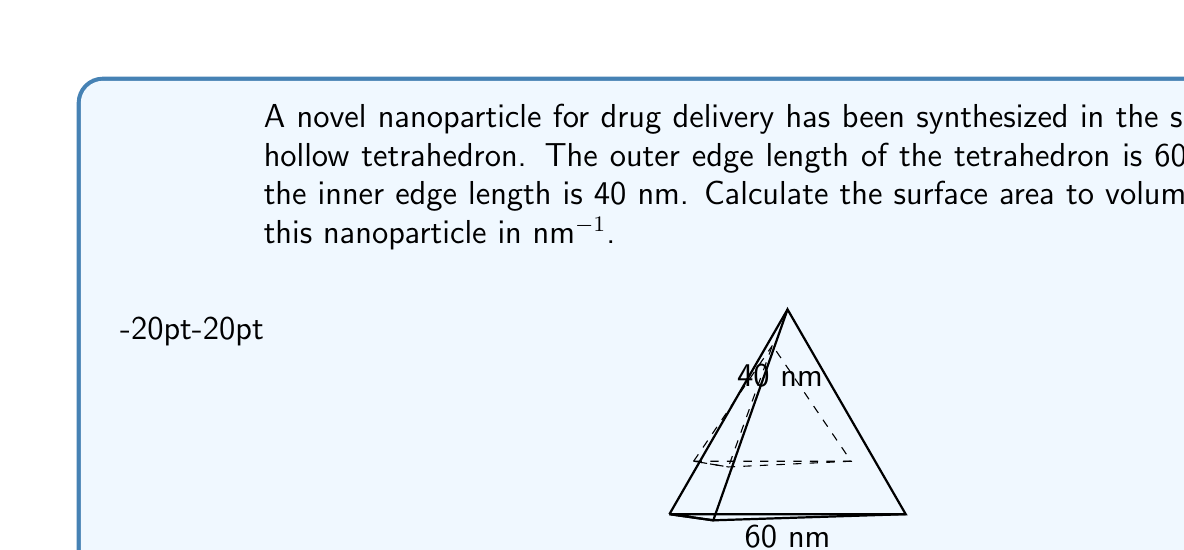Teach me how to tackle this problem. To solve this problem, we need to calculate the surface area and volume of the hollow tetrahedron, then divide the surface area by the volume.

Step 1: Calculate the surface area
The surface area consists of the outer and inner surfaces of the tetrahedron.

For a regular tetrahedron, the surface area is given by:
$$ SA = \sqrt{3} \cdot a^2 $$
where $a$ is the edge length.

Outer surface area: $SA_{outer} = \sqrt{3} \cdot 60^2 = 6235.4$ nm²
Inner surface area: $SA_{inner} = \sqrt{3} \cdot 40^2 = 2771.3$ nm²

Total surface area: $SA_{total} = SA_{outer} + SA_{inner} = 9006.7$ nm²

Step 2: Calculate the volume
The volume of a regular tetrahedron is given by:
$$ V = \frac{a^3}{6\sqrt{2}} $$

Outer volume: $V_{outer} = \frac{60^3}{6\sqrt{2}} = 42426.4$ nm³
Inner volume: $V_{inner} = \frac{40^3}{6\sqrt{2}} = 12578.6$ nm³

Volume of the hollow tetrahedron: $V_{hollow} = V_{outer} - V_{inner} = 29847.8$ nm³

Step 3: Calculate the surface area to volume ratio
$$ \text{SA:V ratio} = \frac{SA_{total}}{V_{hollow}} = \frac{9006.7 \text{ nm}^2}{29847.8 \text{ nm}^3} = 0.3018 \text{ nm}^{-1} $$

Therefore, the surface area to volume ratio of the nanoparticle is approximately 0.3018 nm^-1.
Answer: 0.3018 nm^-1 